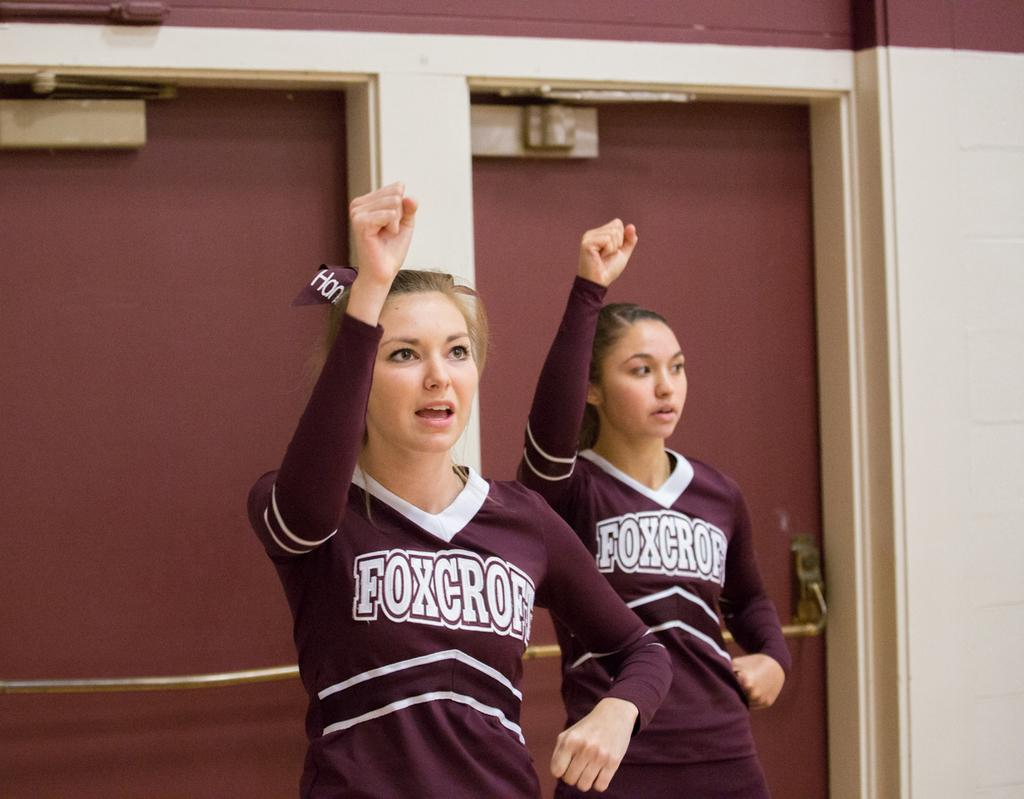<image>
Render a clear and concise summary of the photo. two cheer leaders wearing uniforms with foxcroe on the chest. 